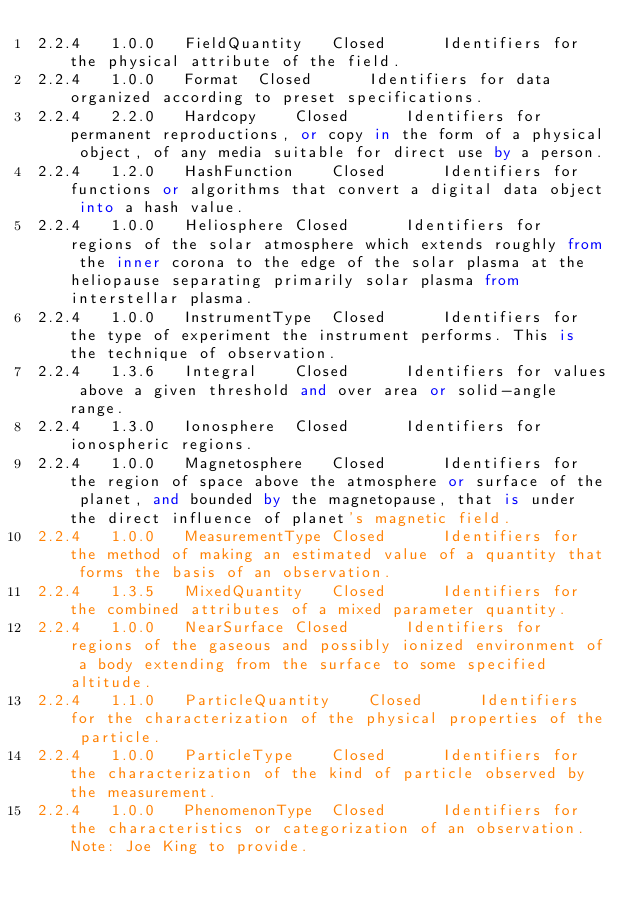<code> <loc_0><loc_0><loc_500><loc_500><_SQL_>2.2.4	1.0.0	FieldQuantity	Closed		Identifiers for the physical attribute of the field.
2.2.4	1.0.0	Format	Closed		Identifiers for data organized according to preset specifications.
2.2.4	2.2.0	Hardcopy	Closed		Identifiers for permanent reproductions, or copy in the form of a physical object, of any media suitable for direct use by a person.
2.2.4	1.2.0	HashFunction	Closed		Identifiers for functions or algorithms that convert a digital data object into a hash value.
2.2.4	1.0.0	Heliosphere	Closed		Identifiers for regions of the solar atmosphere which extends roughly from the inner corona to the edge of the solar plasma at the heliopause separating primarily solar plasma from interstellar plasma.
2.2.4	1.0.0	InstrumentType	Closed		Identifiers for the type of experiment the instrument performs. This is the technique of observation.
2.2.4	1.3.6	Integral	Closed		Identifiers for values above a given threshold and over area or solid-angle range.
2.2.4	1.3.0	Ionosphere	Closed		Identifiers for ionospheric regions.
2.2.4	1.0.0	Magnetosphere	Closed		Identifiers for the region of space above the atmosphere or surface of the planet, and bounded by the magnetopause, that is under the direct influence of planet's magnetic field.
2.2.4	1.0.0	MeasurementType	Closed		Identifiers for the method of making an estimated value of a quantity that forms the basis of an observation.
2.2.4	1.3.5	MixedQuantity	Closed		Identifiers for the combined attributes of a mixed parameter quantity.
2.2.4	1.0.0	NearSurface	Closed		Identifiers for regions of the gaseous and possibly ionized environment of a body extending from the surface to some specified altitude.
2.2.4	1.1.0	ParticleQuantity	Closed		Identifiers for the characterization of the physical properties of the particle.
2.2.4	1.0.0	ParticleType	Closed		Identifiers for the characterization of the kind of particle observed by the measurement.
2.2.4	1.0.0	PhenomenonType	Closed		Identifiers for the characteristics or categorization of an observation. Note: Joe King to provide.</code> 